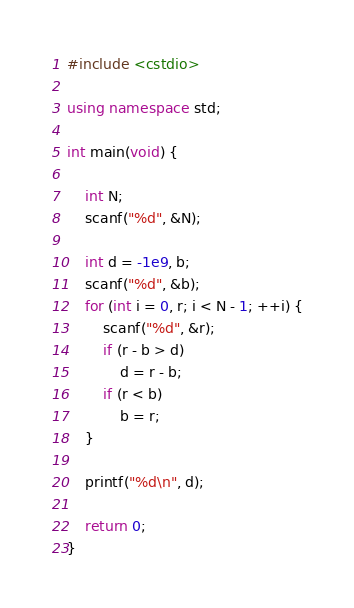Convert code to text. <code><loc_0><loc_0><loc_500><loc_500><_C++_>#include <cstdio>

using namespace std;

int main(void) {

    int N;
    scanf("%d", &N);

    int d = -1e9, b;
    scanf("%d", &b);
    for (int i = 0, r; i < N - 1; ++i) {
        scanf("%d", &r);
        if (r - b > d)
            d = r - b;
        if (r < b)
            b = r;
    }

    printf("%d\n", d);

    return 0;
}</code> 